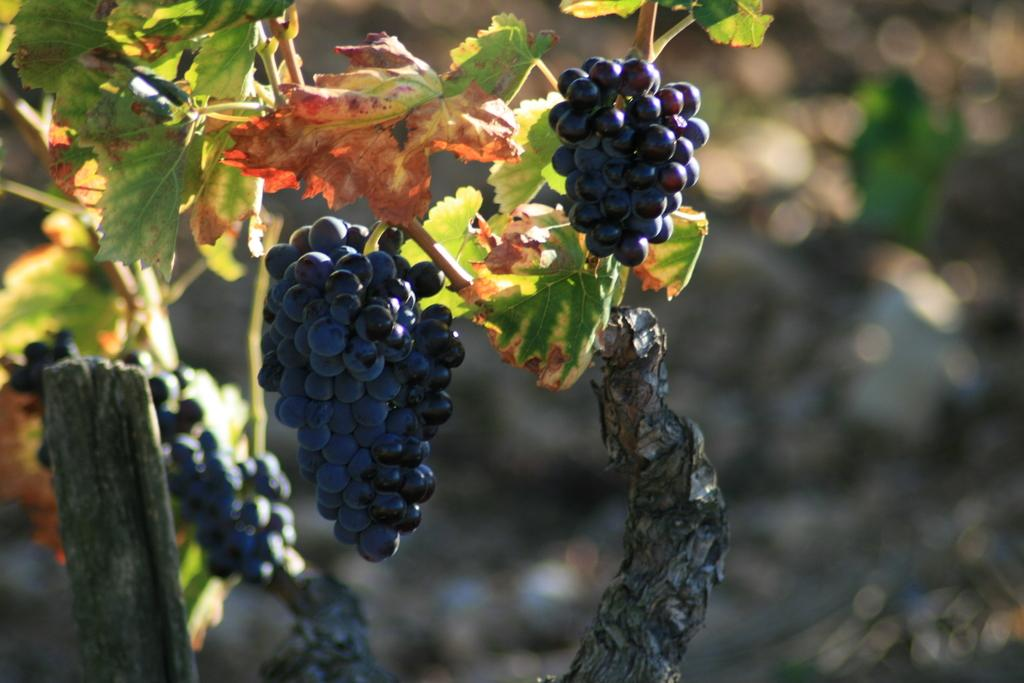What type of fruit is visible in the image? There are grapes in the image. Where are the grapes located in the image? The grapes are hanging on a plant. Can you describe the background of the image? The background of the image is blurry. What type of wilderness can be seen in the background of the image? There is no wilderness visible in the image; the background is blurry. Is there a volleyball game taking place in the image? There is no volleyball game or any reference to volleyball in the image. 